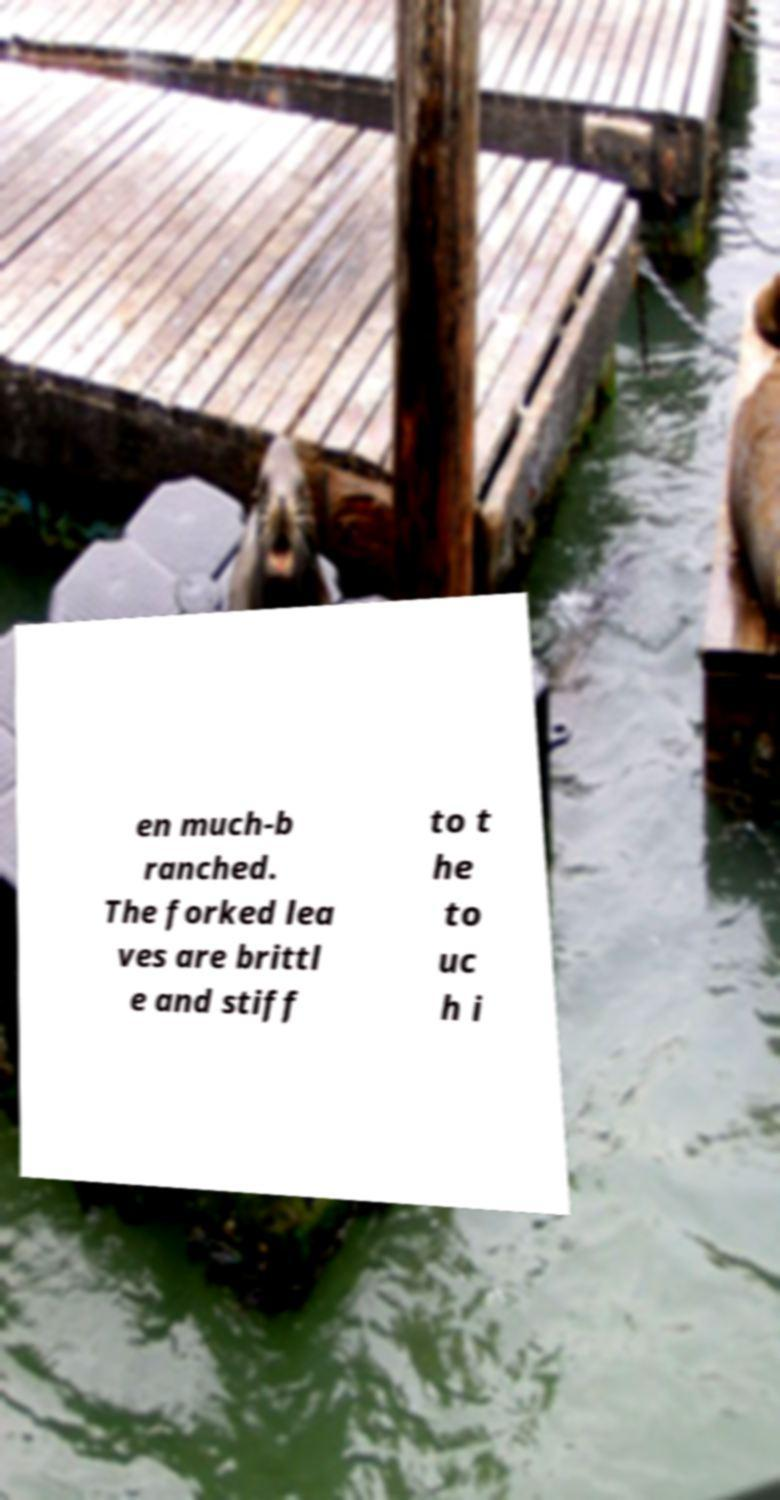Can you accurately transcribe the text from the provided image for me? en much-b ranched. The forked lea ves are brittl e and stiff to t he to uc h i 